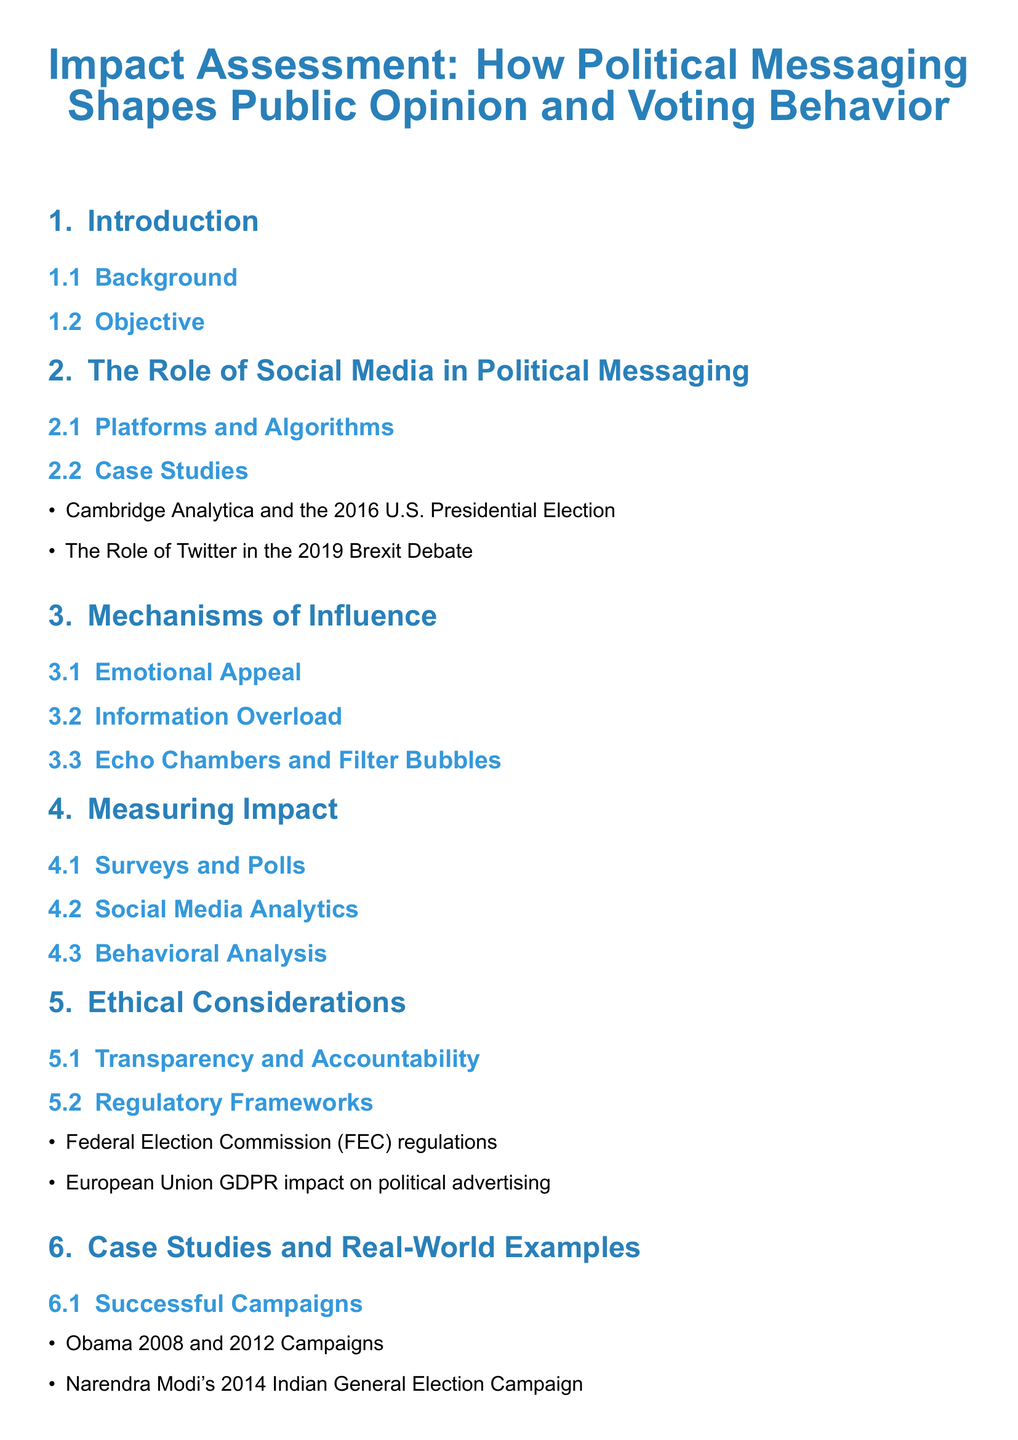What is the title of the document? The title of the document is prominently displayed at the start, indicating the main topic of discussion.
Answer: Impact Assessment: How Political Messaging Shapes Public Opinion and Voting Behavior How many sections are in the document? By counting the main divisions in the table of contents, we can determine the number of sections present.
Answer: 7 What are the two case studies listed in the section on social media? The case studies are specified to illustrate real-world examples of political messaging on social media.
Answer: Cambridge Analytica and the 2016 U.S. Presidential Election, The Role of Twitter in the 2019 Brexit Debate What does the section on ethical considerations address? This section focuses on important aspects regarding the responsible use of political messaging, including regulations.
Answer: Transparency and Accountability, Regulatory Frameworks Which two successful campaign examples are mentioned? The successful campaigns are listed as specific instances where political messaging was effectively utilized.
Answer: Obama 2008 and 2012 Campaigns, Narendra Modi's 2014 Indian General Election Campaign 